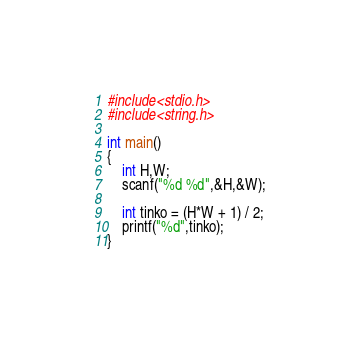<code> <loc_0><loc_0><loc_500><loc_500><_C++_>#include<stdio.h>
#include<string.h>

int main()
{
	int H,W;
	scanf("%d %d",&H,&W);
	
	int tinko = (H*W + 1) / 2;
	printf("%d",tinko);
}</code> 